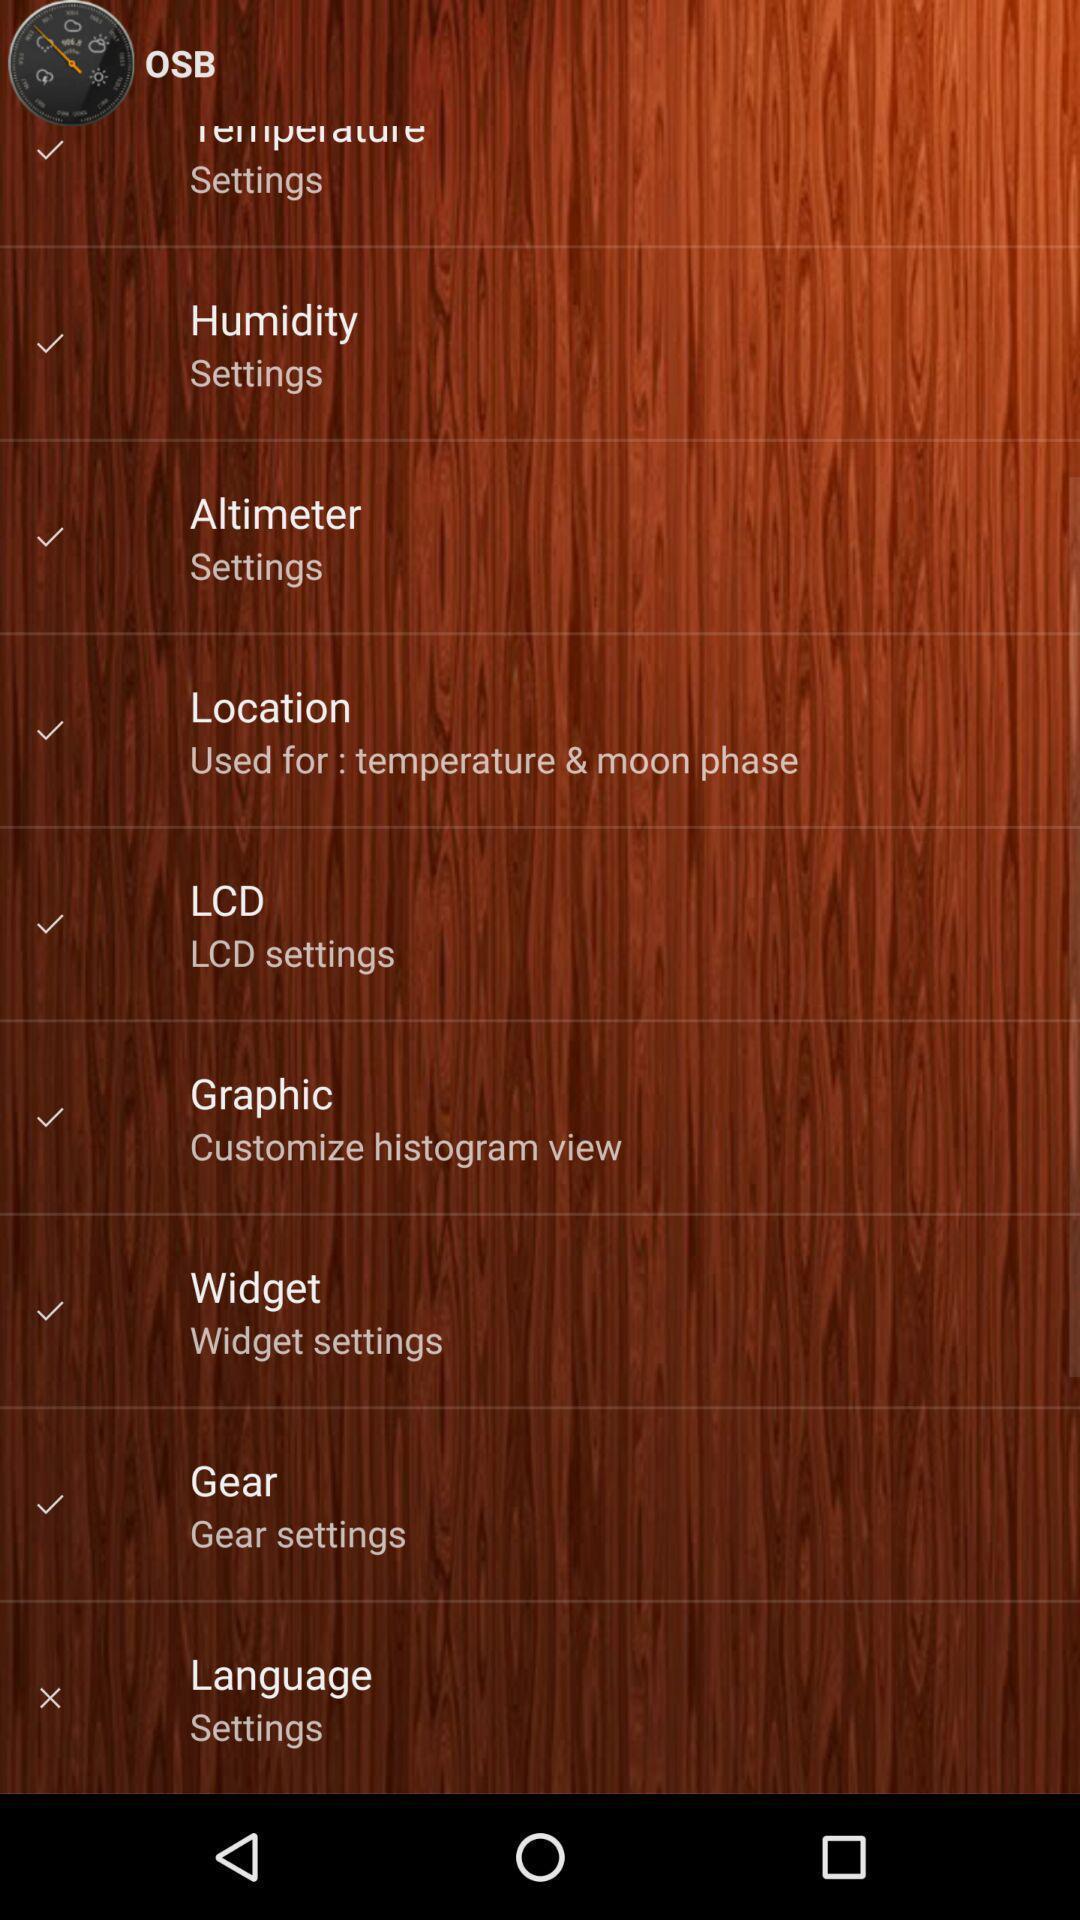Provide a detailed account of this screenshot. Screen showing settings page. 